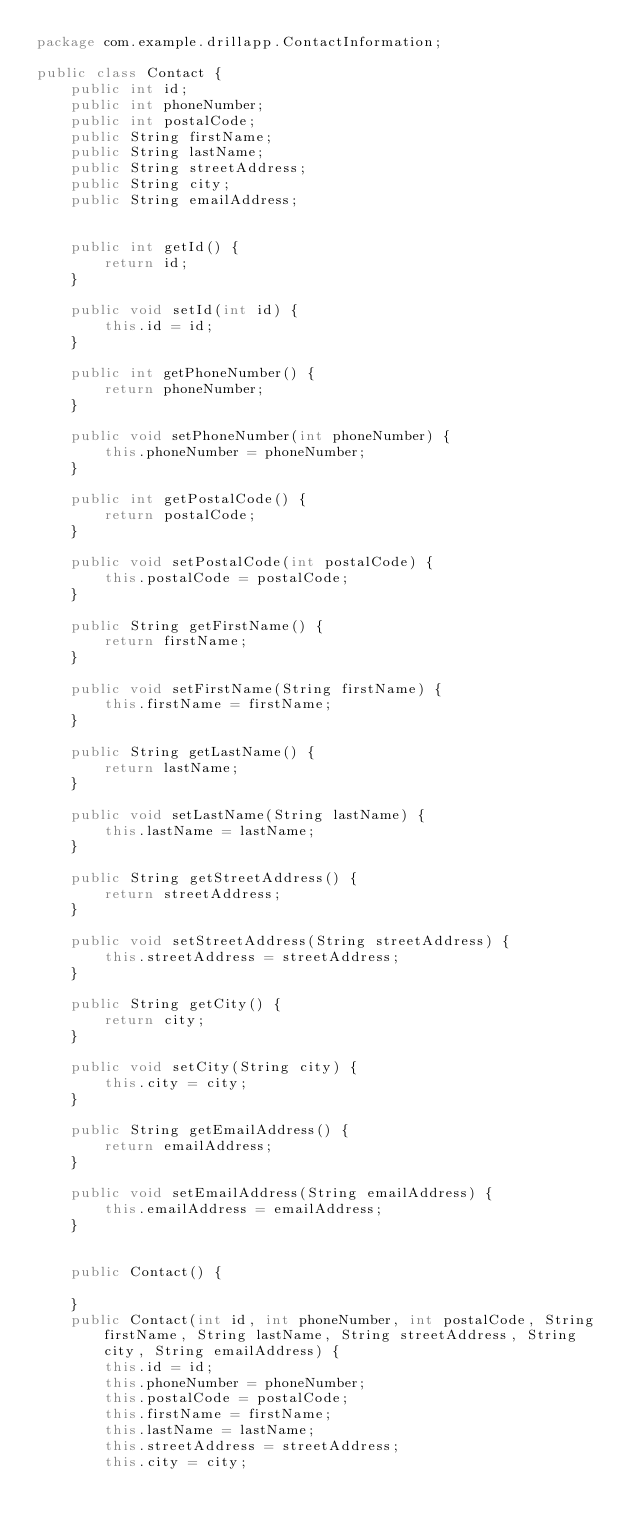<code> <loc_0><loc_0><loc_500><loc_500><_Java_>package com.example.drillapp.ContactInformation;

public class Contact {
    public int id;
    public int phoneNumber;
    public int postalCode;
    public String firstName;
    public String lastName;
    public String streetAddress;
    public String city;
    public String emailAddress;


    public int getId() {
        return id;
    }

    public void setId(int id) {
        this.id = id;
    }

    public int getPhoneNumber() {
        return phoneNumber;
    }

    public void setPhoneNumber(int phoneNumber) {
        this.phoneNumber = phoneNumber;
    }

    public int getPostalCode() {
        return postalCode;
    }

    public void setPostalCode(int postalCode) {
        this.postalCode = postalCode;
    }

    public String getFirstName() {
        return firstName;
    }

    public void setFirstName(String firstName) {
        this.firstName = firstName;
    }

    public String getLastName() {
        return lastName;
    }

    public void setLastName(String lastName) {
        this.lastName = lastName;
    }

    public String getStreetAddress() {
        return streetAddress;
    }

    public void setStreetAddress(String streetAddress) {
        this.streetAddress = streetAddress;
    }

    public String getCity() {
        return city;
    }

    public void setCity(String city) {
        this.city = city;
    }

    public String getEmailAddress() {
        return emailAddress;
    }

    public void setEmailAddress(String emailAddress) {
        this.emailAddress = emailAddress;
    }


    public Contact() {

    }
    public Contact(int id, int phoneNumber, int postalCode, String firstName, String lastName, String streetAddress, String city, String emailAddress) {
        this.id = id;
        this.phoneNumber = phoneNumber;
        this.postalCode = postalCode;
        this.firstName = firstName;
        this.lastName = lastName;
        this.streetAddress = streetAddress;
        this.city = city;</code> 